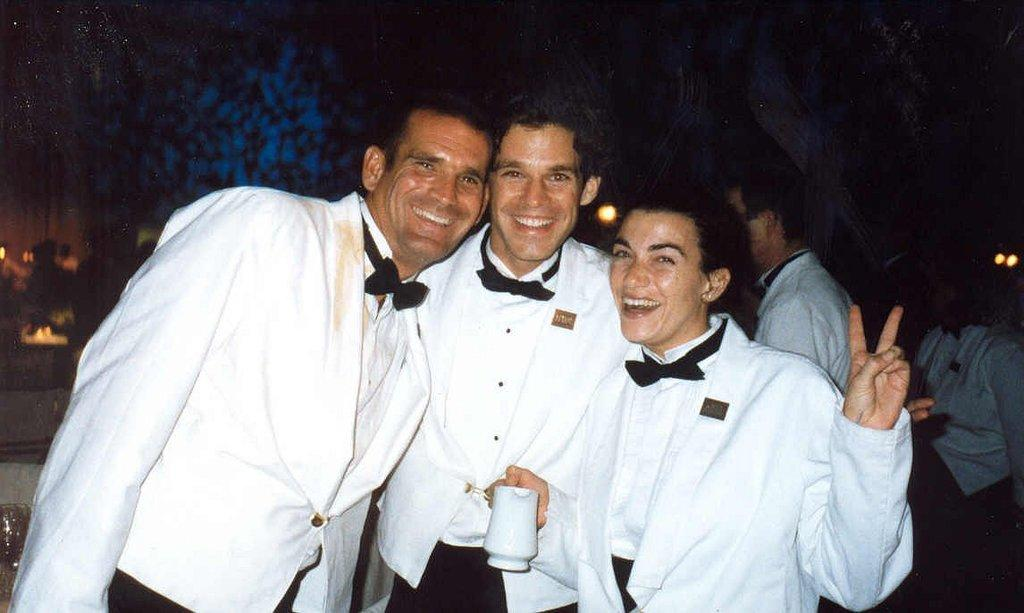Who or what can be seen in the image? There are people in the image. What are the people doing in the image? The people are standing on the floor and smiling. What type of quiver is being used by the people in the image? There is no quiver present in the image; the people are simply standing and smiling. 